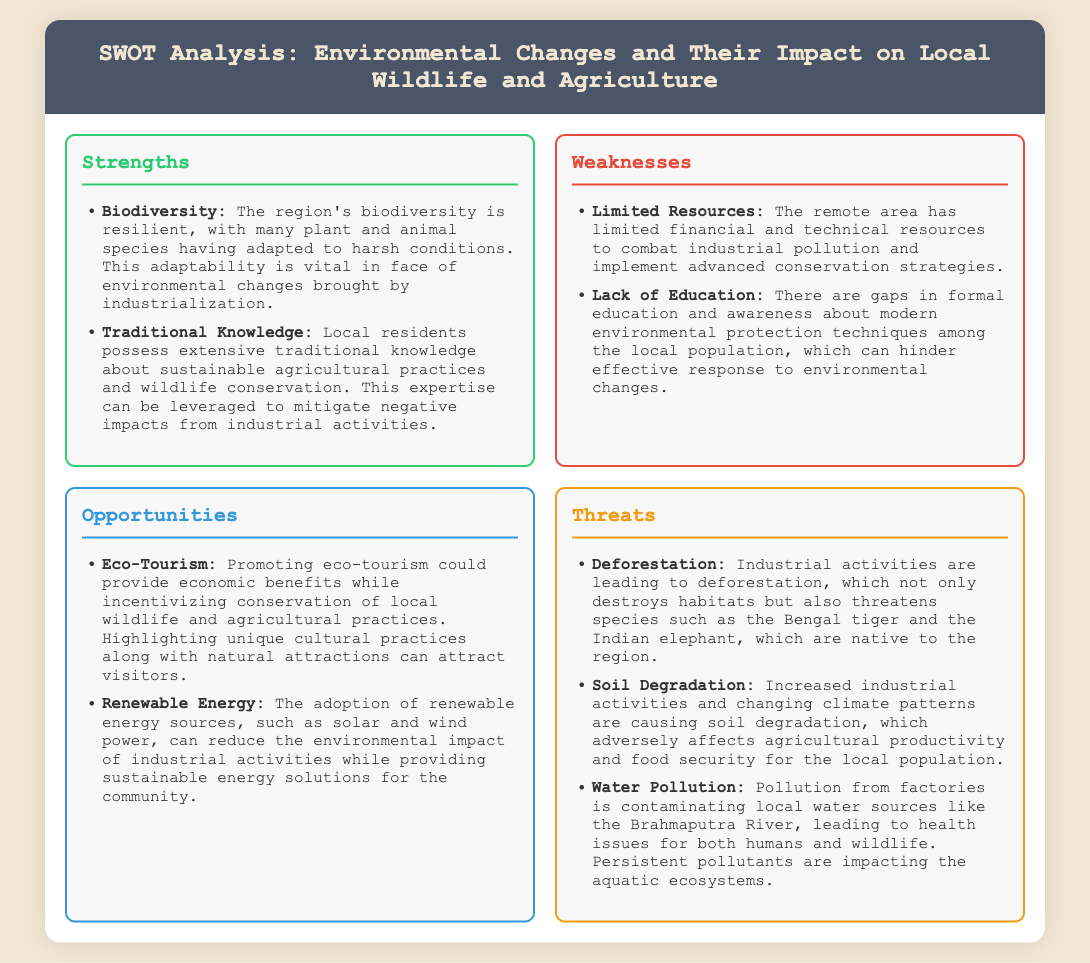What is the title of the document? The title is the main heading presented at the top of the document.
Answer: SWOT Analysis: Environmental Changes and Their Impact on Local Wildlife and Agriculture How many strengths are listed? The strengths section enumerates the positive aspects identified in the analysis.
Answer: 2 What issue does industrialization pose to local wildlife? The threats section mentions specific threats to wildlife due to industrial activities.
Answer: Deforestation What type of economic opportunity is mentioned? The opportunities section discusses potential economic advantages that could arise from specific initiatives.
Answer: Eco-Tourism What is one weakness related to local education? The weaknesses section identifies educational challenges faced by the local population.
Answer: Lack of Education Which renewable energy sources are suggested? The opportunities section proposes specific energy solutions that can benefit the community.
Answer: Solar and wind power What impact does industrial activity have on soil? The threats section describes the adverse effects of industrial activities on natural resources.
Answer: Soil Degradation How does traditional knowledge contribute to sustainability? The strengths section highlights the value of local knowledge in addressing environmental challenges.
Answer: Sustainable agricultural practices 